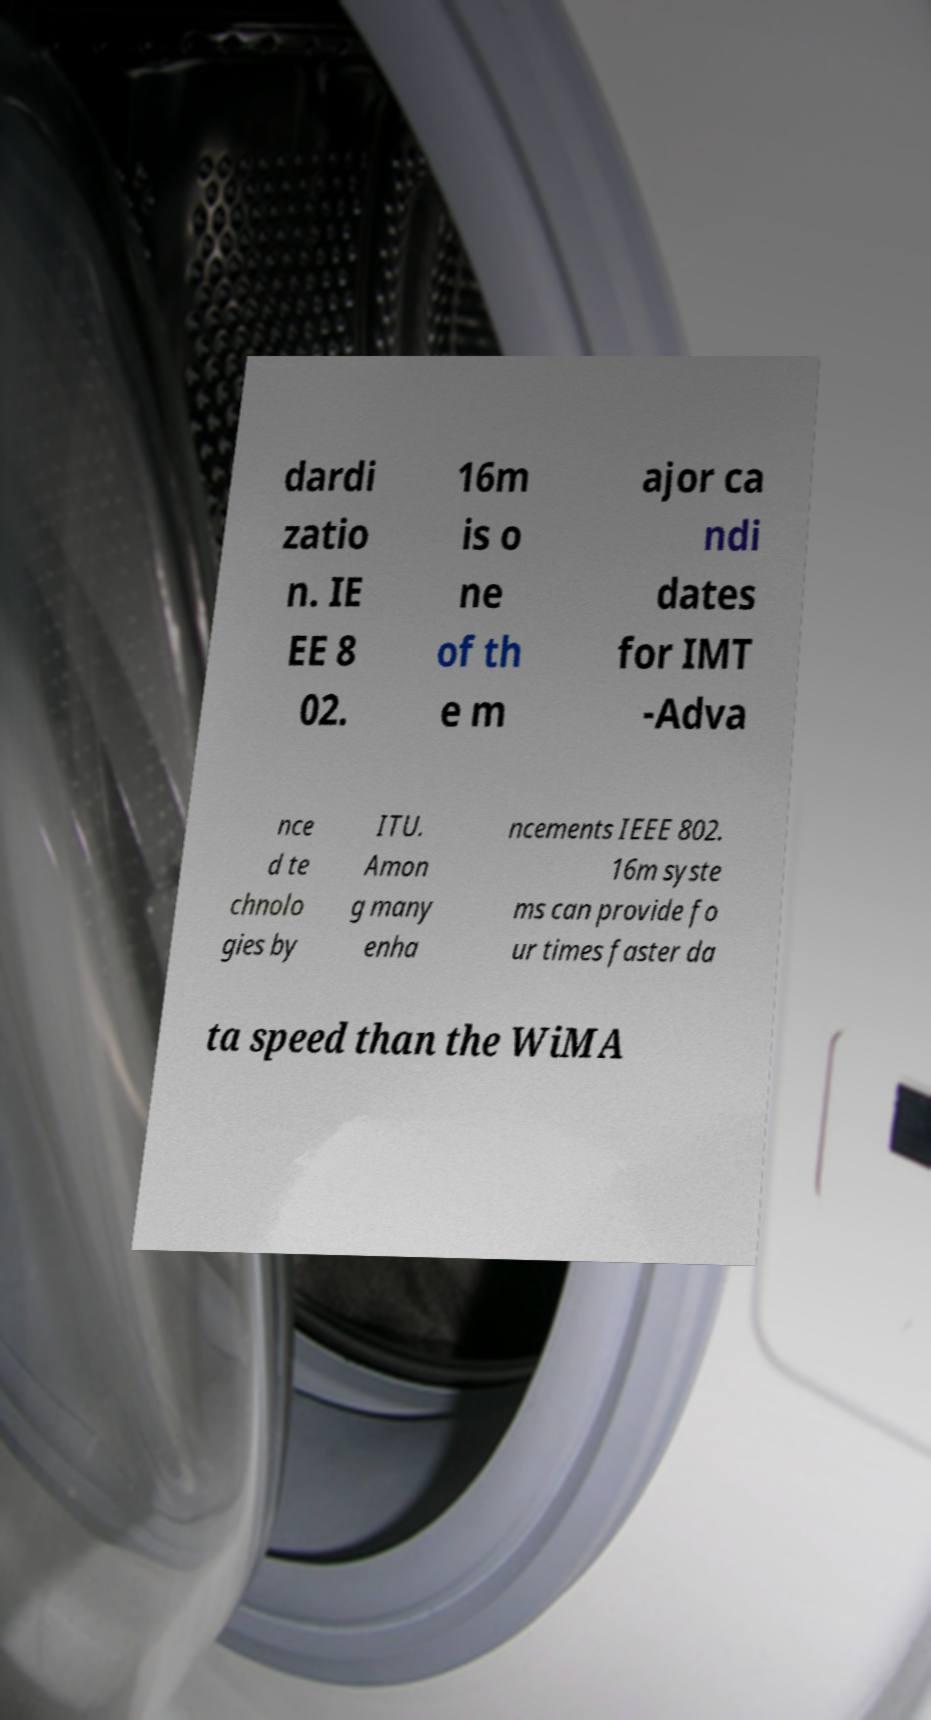Can you accurately transcribe the text from the provided image for me? dardi zatio n. IE EE 8 02. 16m is o ne of th e m ajor ca ndi dates for IMT -Adva nce d te chnolo gies by ITU. Amon g many enha ncements IEEE 802. 16m syste ms can provide fo ur times faster da ta speed than the WiMA 